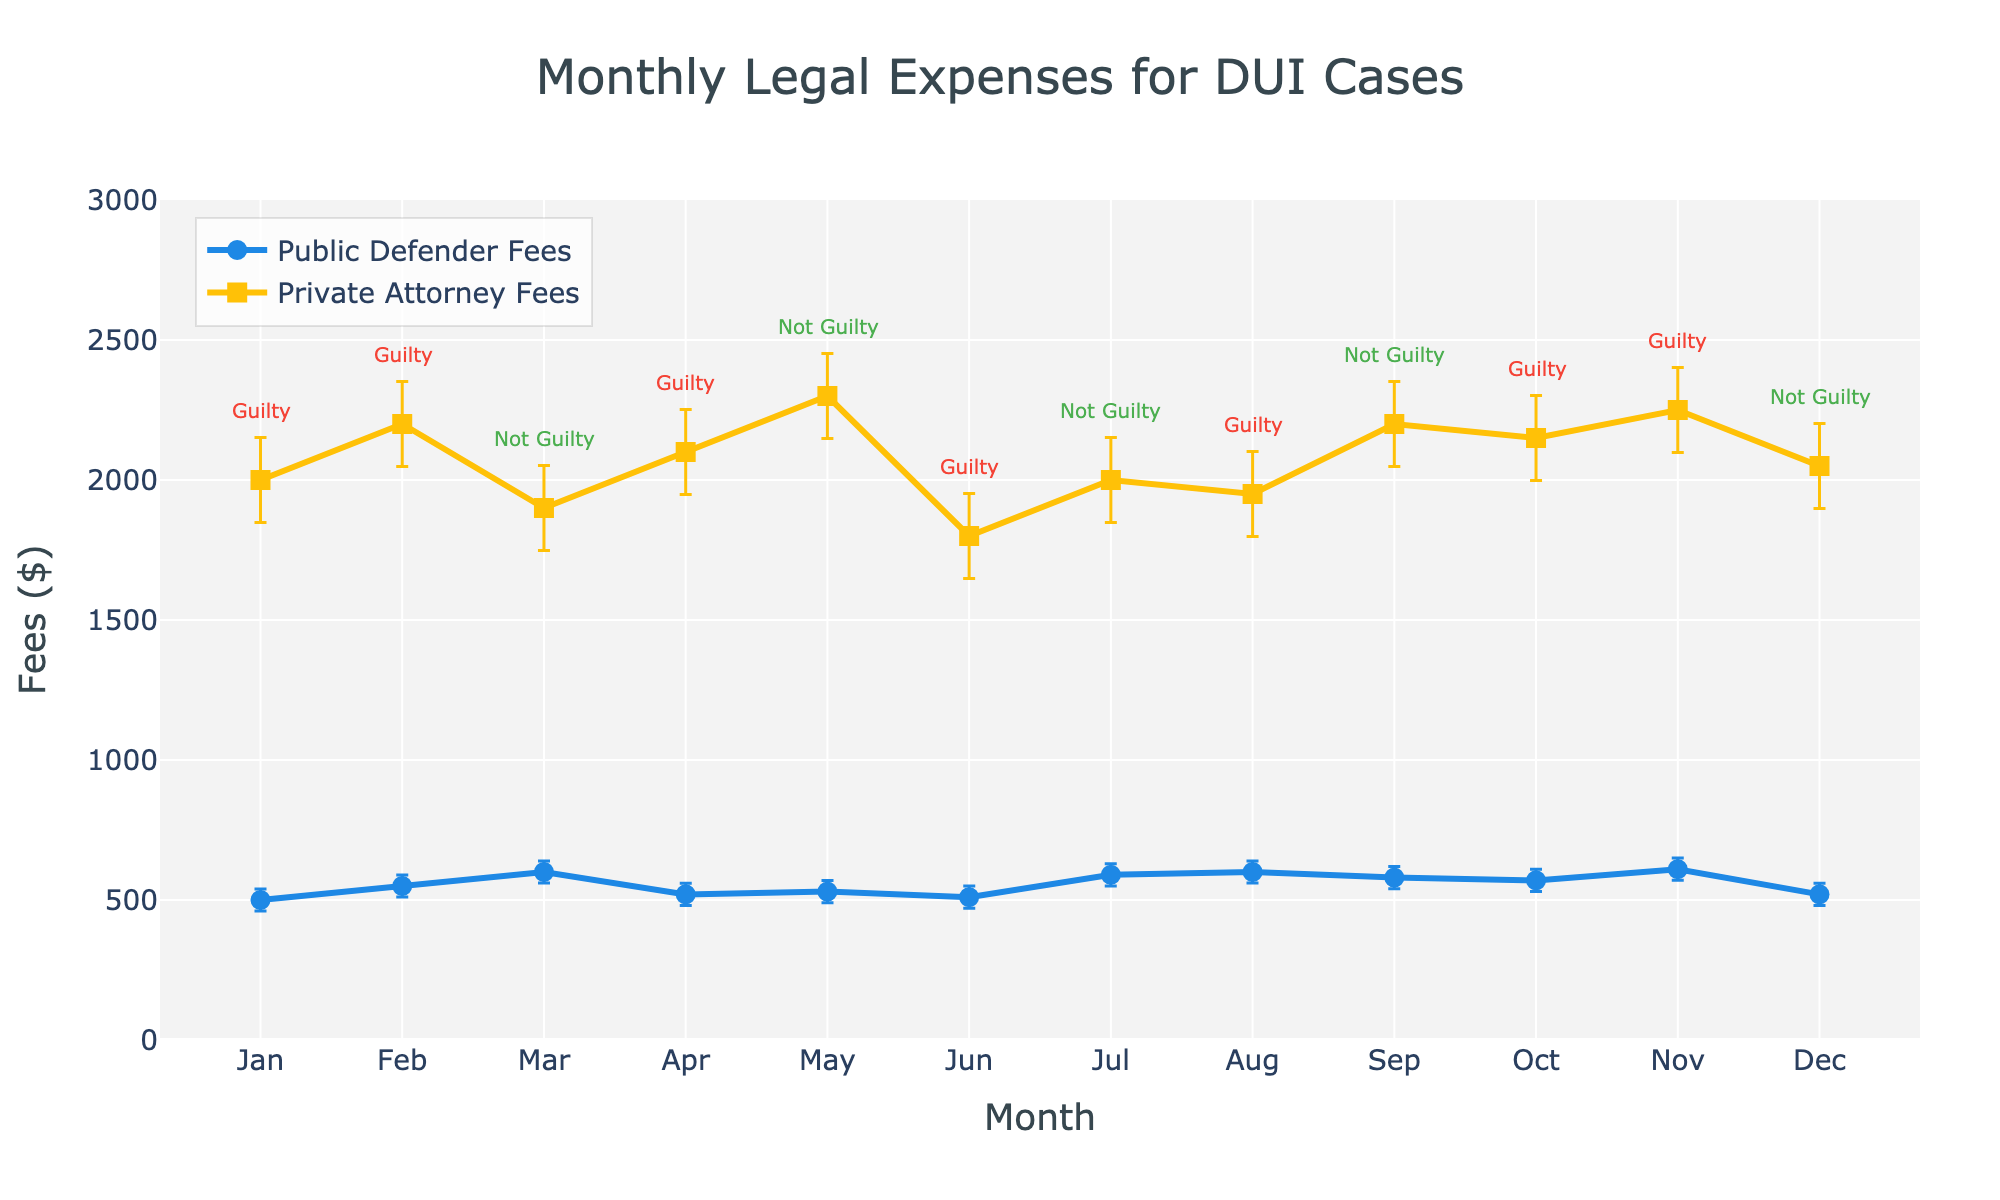How many months are depicted in the plot? The x-axis shows the months, and each point on the plot represents a month. Counting these points gives us the total number of months.
Answer: 12 What are the average fees for a public defender and a private attorney? To find the average fees, sum the monthly fees for each and divide by the number of months (12). For public defender fees: (500+550+600+520+530+510+590+600+580+570+610+520)/12 = 554.17. For private attorney fees: (2000+2200+1900+2100+2300+1800+2000+1950+2200+2150+2250+2050)/12 = 2062.50.
Answer: 554.17, 2062.50 In which month are the public defender fees the highest? By looking at the y-values of the public defender fees (blue line with circle markers), identify the highest point and check its corresponding month on the x-axis. This maximum fee is 610 and occurs in November.
Answer: November Are there any months where the case outcome is 'Not Guilty' and the private attorney fees are above 2000? Check the annotations for 'Not Guilty' and compare their corresponding private attorney fees. This occurs in May and September.
Answer: May and September How does the standard deviation for public defender fees compare to that for private attorney fees? The standard deviation, which is visually represented by the error bars, is constant. The length of the error bars indicates that the standard deviation for private attorney fees is higher compared to public defender fees.
Answer: Higher for private attorney fees During which months do the public defender fees increase sequentially? Observing the blue line with circle markers, identify any sequential increases. The fees increase from January to March.
Answer: January to March Compare the fees and case outcomes for January and July. In January, public defender fees are 500, private attorney fees are 2000, and the outcome is 'Guilty'. In July, public defender fees are 590, private attorney fees are 2000, and the outcome is 'Not Guilty'.
Answer: January: 500, 2000, Guilty; July: 590, 2000, Not Guilty What is the general trend in private attorney fees over the year? Observe the yellow line with square markers. It starts high, drops and fluctuates, but generally stays around a similar level without a clear upward or downward trend.
Answer: No clear trend, fluctuates around a similar level How many times do the public defender and private attorney fees cross each other? Look for points where the blue and yellow lines intersect. Count these intersection points. In this case, they intersect once, in March.
Answer: Once 